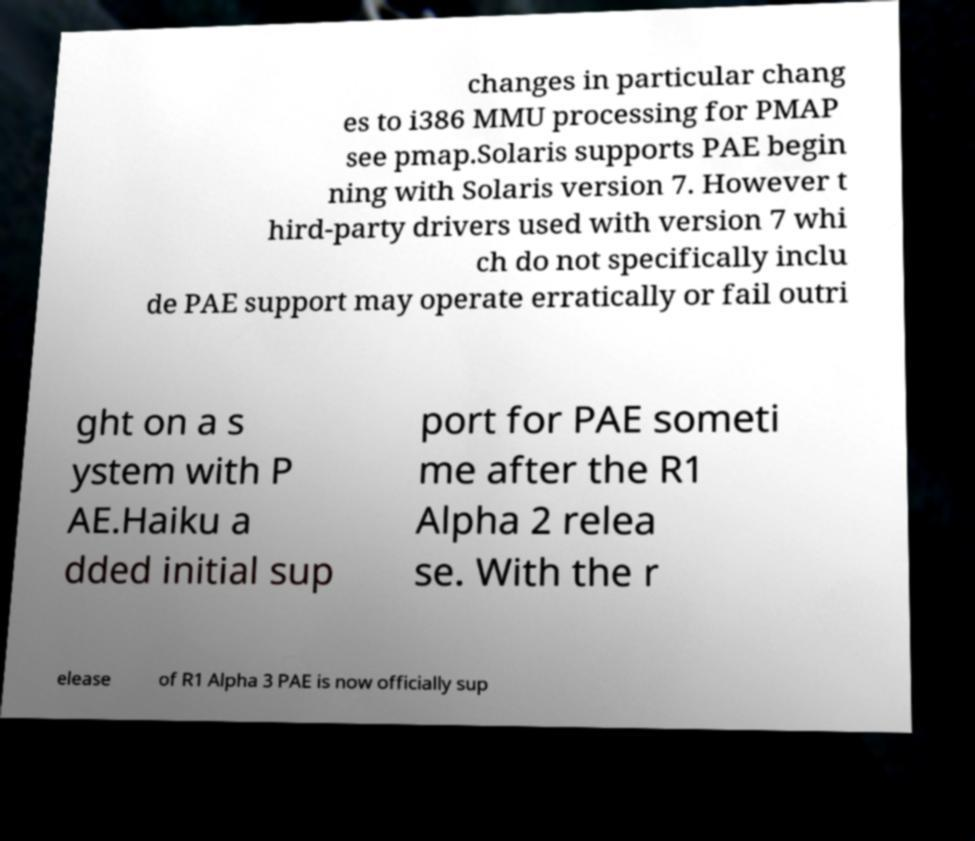What messages or text are displayed in this image? I need them in a readable, typed format. changes in particular chang es to i386 MMU processing for PMAP see pmap.Solaris supports PAE begin ning with Solaris version 7. However t hird-party drivers used with version 7 whi ch do not specifically inclu de PAE support may operate erratically or fail outri ght on a s ystem with P AE.Haiku a dded initial sup port for PAE someti me after the R1 Alpha 2 relea se. With the r elease of R1 Alpha 3 PAE is now officially sup 